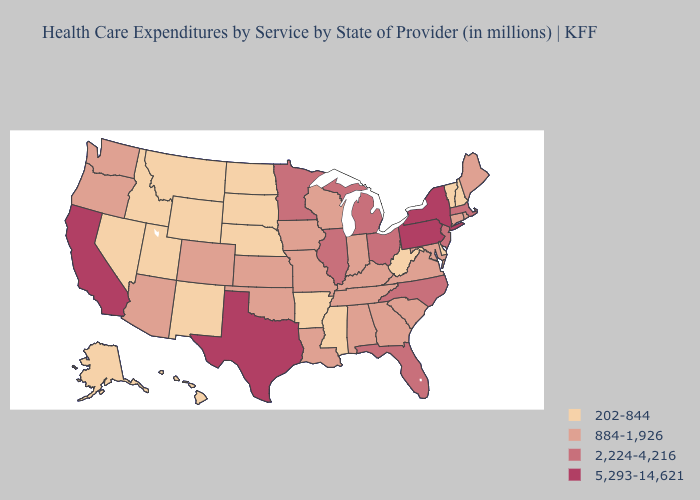Does the first symbol in the legend represent the smallest category?
Write a very short answer. Yes. Does Alabama have the lowest value in the USA?
Keep it brief. No. Does West Virginia have the highest value in the South?
Keep it brief. No. Is the legend a continuous bar?
Quick response, please. No. What is the lowest value in the MidWest?
Give a very brief answer. 202-844. Does West Virginia have a lower value than Pennsylvania?
Write a very short answer. Yes. What is the value of Connecticut?
Quick response, please. 884-1,926. Does Florida have the same value as Ohio?
Concise answer only. Yes. Name the states that have a value in the range 884-1,926?
Be succinct. Alabama, Arizona, Colorado, Connecticut, Georgia, Indiana, Iowa, Kansas, Kentucky, Louisiana, Maine, Maryland, Missouri, Oklahoma, Oregon, Rhode Island, South Carolina, Tennessee, Virginia, Washington, Wisconsin. What is the value of Montana?
Be succinct. 202-844. Which states have the lowest value in the USA?
Keep it brief. Alaska, Arkansas, Delaware, Hawaii, Idaho, Mississippi, Montana, Nebraska, Nevada, New Hampshire, New Mexico, North Dakota, South Dakota, Utah, Vermont, West Virginia, Wyoming. Does the first symbol in the legend represent the smallest category?
Quick response, please. Yes. Does South Dakota have a lower value than Kentucky?
Concise answer only. Yes. Does Utah have a higher value than Idaho?
Short answer required. No. What is the value of Idaho?
Write a very short answer. 202-844. 